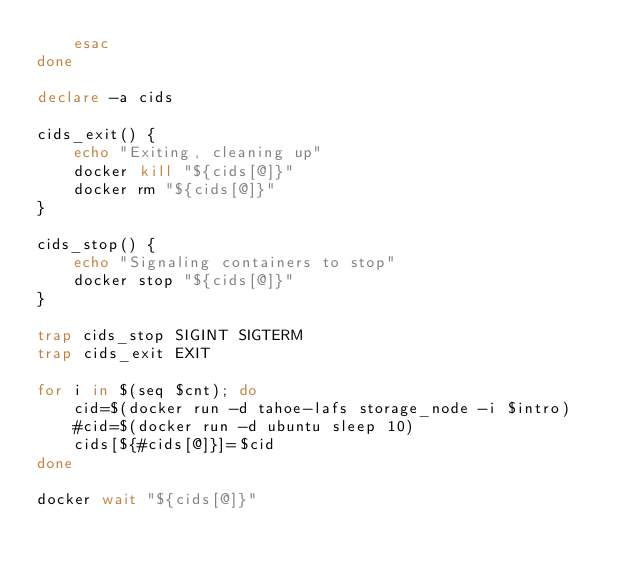Convert code to text. <code><loc_0><loc_0><loc_500><loc_500><_Bash_>    esac
done

declare -a cids

cids_exit() {
    echo "Exiting, cleaning up"
    docker kill "${cids[@]}"
    docker rm "${cids[@]}"
}

cids_stop() {
    echo "Signaling containers to stop"
    docker stop "${cids[@]}"
}

trap cids_stop SIGINT SIGTERM
trap cids_exit EXIT

for i in $(seq $cnt); do
    cid=$(docker run -d tahoe-lafs storage_node -i $intro)
    #cid=$(docker run -d ubuntu sleep 10)
    cids[${#cids[@]}]=$cid
done

docker wait "${cids[@]}"
</code> 